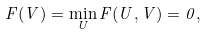Convert formula to latex. <formula><loc_0><loc_0><loc_500><loc_500>F ( V ) = \min _ { U } F ( U , V ) = 0 ,</formula> 